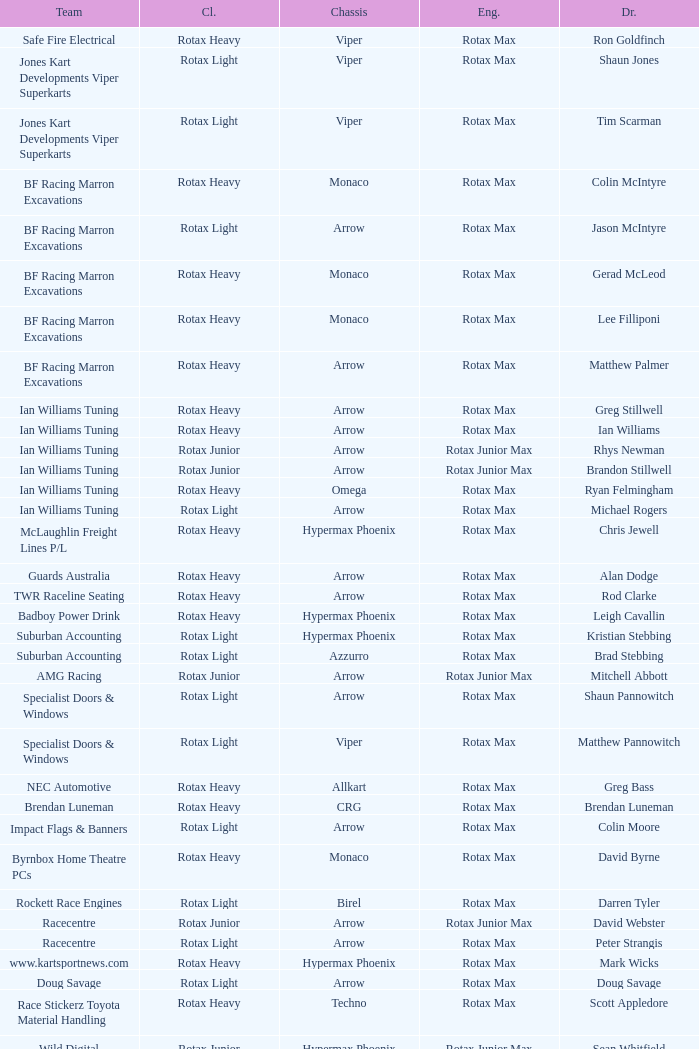Driver Shaun Jones with a viper as a chassis is in what class? Rotax Light. 